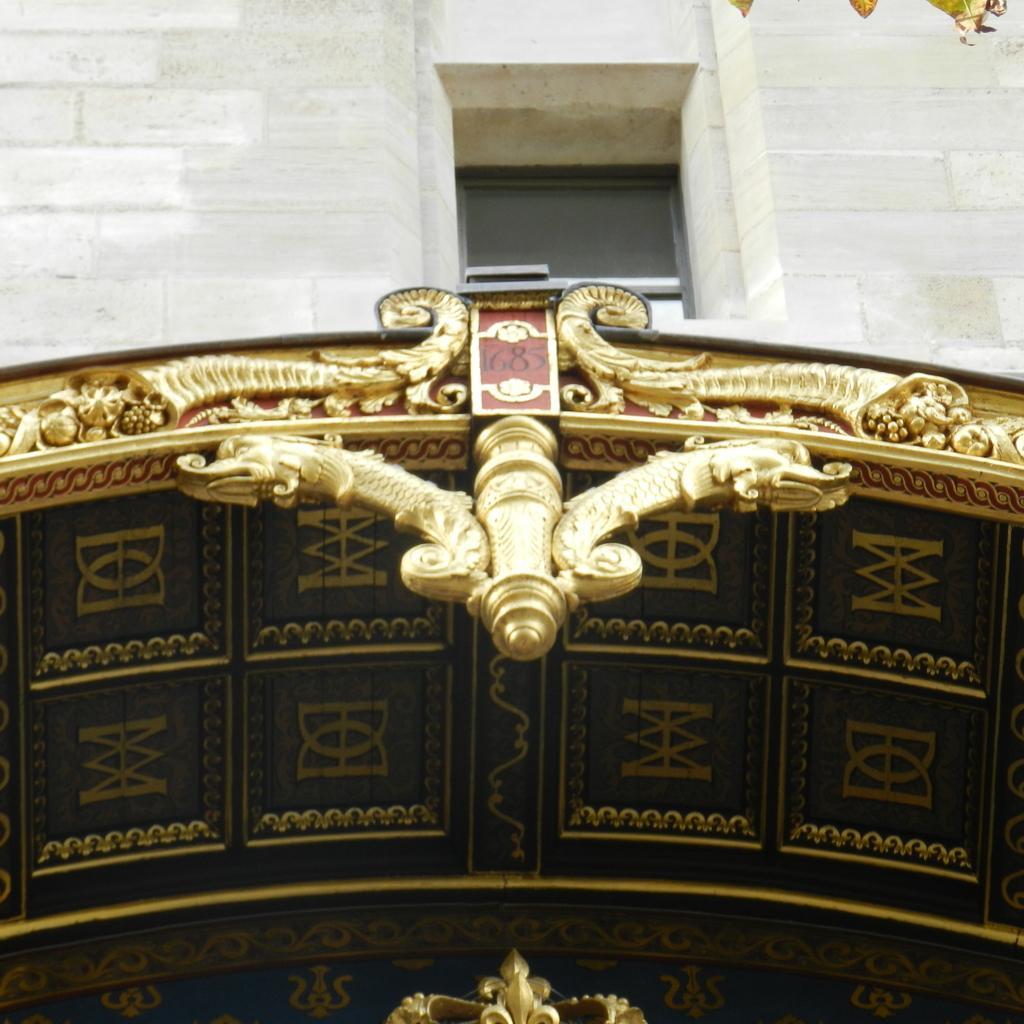Could you give a brief overview of what you see in this image? In this picture, it is looking like a gold color ceiling with a board and on top of it there is a wall. 